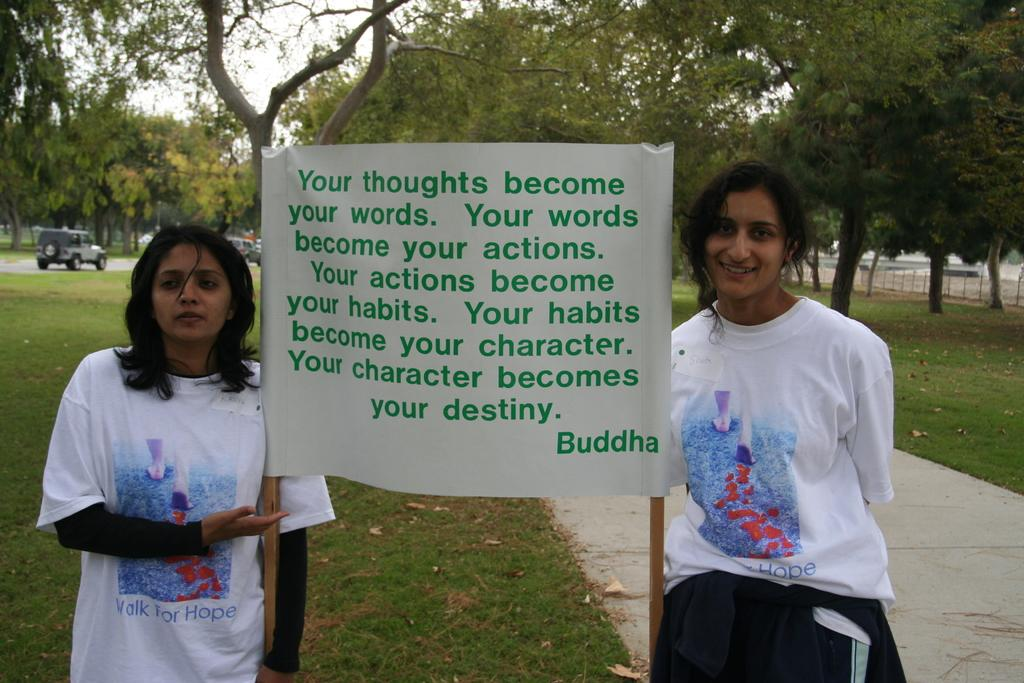<image>
Share a concise interpretation of the image provided. Two women holding a sign with a quote from Buddha. 